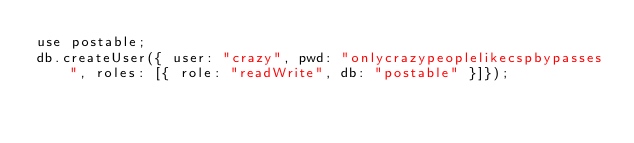<code> <loc_0><loc_0><loc_500><loc_500><_JavaScript_>use postable;
db.createUser({ user: "crazy", pwd: "onlycrazypeoplelikecspbypasses", roles: [{ role: "readWrite", db: "postable" }]});
</code> 